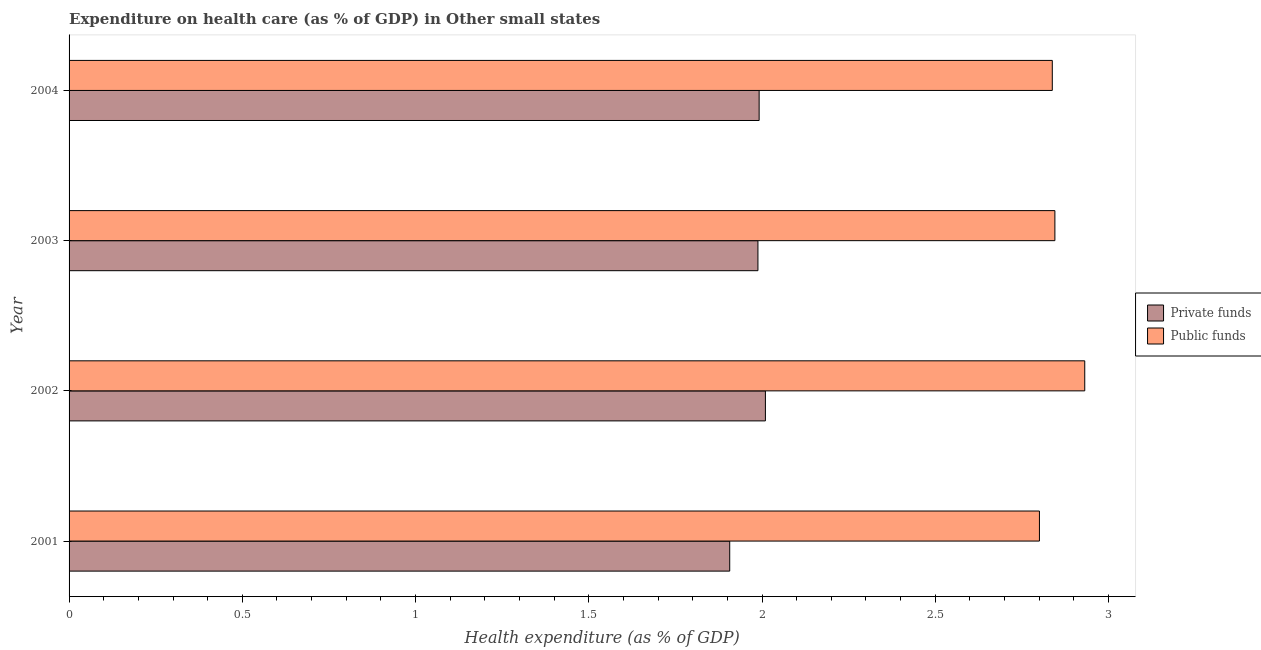How many different coloured bars are there?
Keep it short and to the point. 2. How many groups of bars are there?
Your answer should be very brief. 4. What is the label of the 2nd group of bars from the top?
Provide a succinct answer. 2003. In how many cases, is the number of bars for a given year not equal to the number of legend labels?
Ensure brevity in your answer.  0. What is the amount of private funds spent in healthcare in 2003?
Give a very brief answer. 1.99. Across all years, what is the maximum amount of private funds spent in healthcare?
Your answer should be very brief. 2.01. Across all years, what is the minimum amount of private funds spent in healthcare?
Make the answer very short. 1.91. In which year was the amount of private funds spent in healthcare minimum?
Offer a very short reply. 2001. What is the total amount of private funds spent in healthcare in the graph?
Your response must be concise. 7.9. What is the difference between the amount of public funds spent in healthcare in 2001 and that in 2002?
Your answer should be compact. -0.13. What is the difference between the amount of private funds spent in healthcare in 2002 and the amount of public funds spent in healthcare in 2001?
Your answer should be very brief. -0.79. What is the average amount of public funds spent in healthcare per year?
Give a very brief answer. 2.85. In the year 2002, what is the difference between the amount of public funds spent in healthcare and amount of private funds spent in healthcare?
Give a very brief answer. 0.92. What is the ratio of the amount of public funds spent in healthcare in 2002 to that in 2004?
Your answer should be compact. 1.03. Is the amount of public funds spent in healthcare in 2002 less than that in 2004?
Provide a short and direct response. No. Is the difference between the amount of private funds spent in healthcare in 2002 and 2004 greater than the difference between the amount of public funds spent in healthcare in 2002 and 2004?
Offer a very short reply. No. What is the difference between the highest and the second highest amount of private funds spent in healthcare?
Offer a very short reply. 0.02. What is the difference between the highest and the lowest amount of public funds spent in healthcare?
Keep it short and to the point. 0.13. In how many years, is the amount of private funds spent in healthcare greater than the average amount of private funds spent in healthcare taken over all years?
Provide a short and direct response. 3. Is the sum of the amount of private funds spent in healthcare in 2001 and 2004 greater than the maximum amount of public funds spent in healthcare across all years?
Ensure brevity in your answer.  Yes. What does the 2nd bar from the top in 2002 represents?
Keep it short and to the point. Private funds. What does the 1st bar from the bottom in 2004 represents?
Your answer should be very brief. Private funds. How many years are there in the graph?
Your response must be concise. 4. What is the difference between two consecutive major ticks on the X-axis?
Offer a terse response. 0.5. Are the values on the major ticks of X-axis written in scientific E-notation?
Your answer should be very brief. No. Does the graph contain any zero values?
Your response must be concise. No. What is the title of the graph?
Your answer should be compact. Expenditure on health care (as % of GDP) in Other small states. What is the label or title of the X-axis?
Provide a short and direct response. Health expenditure (as % of GDP). What is the label or title of the Y-axis?
Ensure brevity in your answer.  Year. What is the Health expenditure (as % of GDP) of Private funds in 2001?
Provide a succinct answer. 1.91. What is the Health expenditure (as % of GDP) of Public funds in 2001?
Your response must be concise. 2.8. What is the Health expenditure (as % of GDP) of Private funds in 2002?
Offer a very short reply. 2.01. What is the Health expenditure (as % of GDP) of Public funds in 2002?
Offer a terse response. 2.93. What is the Health expenditure (as % of GDP) of Private funds in 2003?
Make the answer very short. 1.99. What is the Health expenditure (as % of GDP) of Public funds in 2003?
Make the answer very short. 2.85. What is the Health expenditure (as % of GDP) of Private funds in 2004?
Ensure brevity in your answer.  1.99. What is the Health expenditure (as % of GDP) in Public funds in 2004?
Provide a succinct answer. 2.84. Across all years, what is the maximum Health expenditure (as % of GDP) in Private funds?
Offer a terse response. 2.01. Across all years, what is the maximum Health expenditure (as % of GDP) of Public funds?
Make the answer very short. 2.93. Across all years, what is the minimum Health expenditure (as % of GDP) in Private funds?
Keep it short and to the point. 1.91. Across all years, what is the minimum Health expenditure (as % of GDP) in Public funds?
Provide a succinct answer. 2.8. What is the total Health expenditure (as % of GDP) in Private funds in the graph?
Provide a succinct answer. 7.9. What is the total Health expenditure (as % of GDP) of Public funds in the graph?
Your response must be concise. 11.42. What is the difference between the Health expenditure (as % of GDP) of Private funds in 2001 and that in 2002?
Your response must be concise. -0.1. What is the difference between the Health expenditure (as % of GDP) in Public funds in 2001 and that in 2002?
Offer a terse response. -0.13. What is the difference between the Health expenditure (as % of GDP) of Private funds in 2001 and that in 2003?
Keep it short and to the point. -0.08. What is the difference between the Health expenditure (as % of GDP) in Public funds in 2001 and that in 2003?
Give a very brief answer. -0.04. What is the difference between the Health expenditure (as % of GDP) of Private funds in 2001 and that in 2004?
Offer a very short reply. -0.08. What is the difference between the Health expenditure (as % of GDP) in Public funds in 2001 and that in 2004?
Provide a succinct answer. -0.04. What is the difference between the Health expenditure (as % of GDP) of Private funds in 2002 and that in 2003?
Provide a short and direct response. 0.02. What is the difference between the Health expenditure (as % of GDP) of Public funds in 2002 and that in 2003?
Provide a short and direct response. 0.09. What is the difference between the Health expenditure (as % of GDP) in Private funds in 2002 and that in 2004?
Offer a very short reply. 0.02. What is the difference between the Health expenditure (as % of GDP) in Public funds in 2002 and that in 2004?
Provide a short and direct response. 0.09. What is the difference between the Health expenditure (as % of GDP) of Private funds in 2003 and that in 2004?
Provide a short and direct response. -0. What is the difference between the Health expenditure (as % of GDP) of Public funds in 2003 and that in 2004?
Your response must be concise. 0.01. What is the difference between the Health expenditure (as % of GDP) of Private funds in 2001 and the Health expenditure (as % of GDP) of Public funds in 2002?
Make the answer very short. -1.02. What is the difference between the Health expenditure (as % of GDP) in Private funds in 2001 and the Health expenditure (as % of GDP) in Public funds in 2003?
Your response must be concise. -0.94. What is the difference between the Health expenditure (as % of GDP) of Private funds in 2001 and the Health expenditure (as % of GDP) of Public funds in 2004?
Provide a short and direct response. -0.93. What is the difference between the Health expenditure (as % of GDP) of Private funds in 2002 and the Health expenditure (as % of GDP) of Public funds in 2003?
Your answer should be very brief. -0.84. What is the difference between the Health expenditure (as % of GDP) of Private funds in 2002 and the Health expenditure (as % of GDP) of Public funds in 2004?
Your answer should be compact. -0.83. What is the difference between the Health expenditure (as % of GDP) in Private funds in 2003 and the Health expenditure (as % of GDP) in Public funds in 2004?
Offer a terse response. -0.85. What is the average Health expenditure (as % of GDP) of Private funds per year?
Your response must be concise. 1.97. What is the average Health expenditure (as % of GDP) of Public funds per year?
Offer a terse response. 2.85. In the year 2001, what is the difference between the Health expenditure (as % of GDP) in Private funds and Health expenditure (as % of GDP) in Public funds?
Provide a short and direct response. -0.89. In the year 2002, what is the difference between the Health expenditure (as % of GDP) of Private funds and Health expenditure (as % of GDP) of Public funds?
Give a very brief answer. -0.92. In the year 2003, what is the difference between the Health expenditure (as % of GDP) of Private funds and Health expenditure (as % of GDP) of Public funds?
Your response must be concise. -0.86. In the year 2004, what is the difference between the Health expenditure (as % of GDP) in Private funds and Health expenditure (as % of GDP) in Public funds?
Provide a short and direct response. -0.85. What is the ratio of the Health expenditure (as % of GDP) in Private funds in 2001 to that in 2002?
Ensure brevity in your answer.  0.95. What is the ratio of the Health expenditure (as % of GDP) of Public funds in 2001 to that in 2002?
Provide a short and direct response. 0.96. What is the ratio of the Health expenditure (as % of GDP) of Private funds in 2001 to that in 2003?
Provide a succinct answer. 0.96. What is the ratio of the Health expenditure (as % of GDP) of Public funds in 2001 to that in 2003?
Ensure brevity in your answer.  0.98. What is the ratio of the Health expenditure (as % of GDP) of Private funds in 2001 to that in 2004?
Your answer should be very brief. 0.96. What is the ratio of the Health expenditure (as % of GDP) in Public funds in 2001 to that in 2004?
Offer a very short reply. 0.99. What is the ratio of the Health expenditure (as % of GDP) of Private funds in 2002 to that in 2003?
Offer a very short reply. 1.01. What is the ratio of the Health expenditure (as % of GDP) in Public funds in 2002 to that in 2003?
Keep it short and to the point. 1.03. What is the ratio of the Health expenditure (as % of GDP) of Private funds in 2002 to that in 2004?
Provide a succinct answer. 1.01. What is the ratio of the Health expenditure (as % of GDP) of Public funds in 2002 to that in 2004?
Your answer should be very brief. 1.03. What is the ratio of the Health expenditure (as % of GDP) in Private funds in 2003 to that in 2004?
Keep it short and to the point. 1. What is the difference between the highest and the second highest Health expenditure (as % of GDP) in Private funds?
Provide a short and direct response. 0.02. What is the difference between the highest and the second highest Health expenditure (as % of GDP) of Public funds?
Make the answer very short. 0.09. What is the difference between the highest and the lowest Health expenditure (as % of GDP) in Private funds?
Make the answer very short. 0.1. What is the difference between the highest and the lowest Health expenditure (as % of GDP) of Public funds?
Your response must be concise. 0.13. 